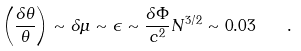Convert formula to latex. <formula><loc_0><loc_0><loc_500><loc_500>\left ( \frac { \delta \theta } { \theta } \right ) \sim \delta \mu \sim \epsilon \sim \frac { \delta \Phi } { c ^ { 2 } } N ^ { 3 / 2 } \sim 0 . 0 3 \quad .</formula> 